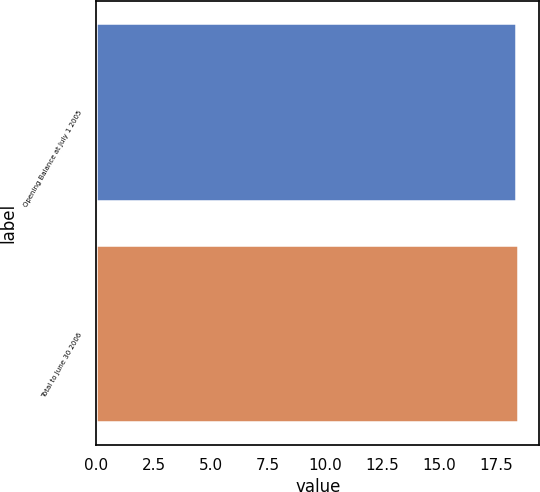<chart> <loc_0><loc_0><loc_500><loc_500><bar_chart><fcel>Opening Balance at July 1 2005<fcel>Total to June 30 2006<nl><fcel>18.36<fcel>18.46<nl></chart> 